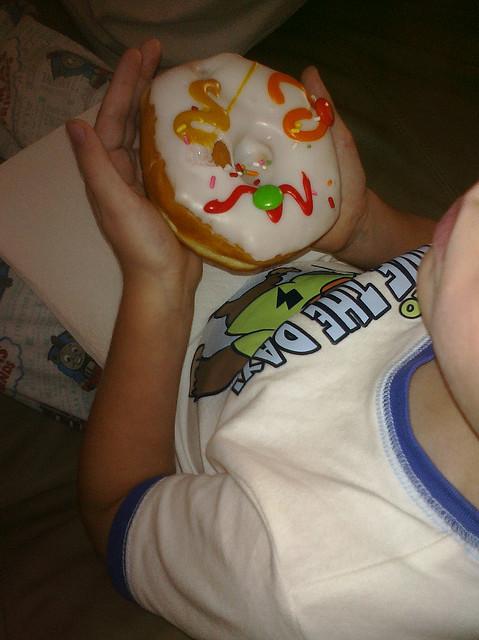Where is the donuts?
Quick response, please. Hands. What is this child holding?
Quick response, please. Donut. Is that a skittle?
Give a very brief answer. Yes. 